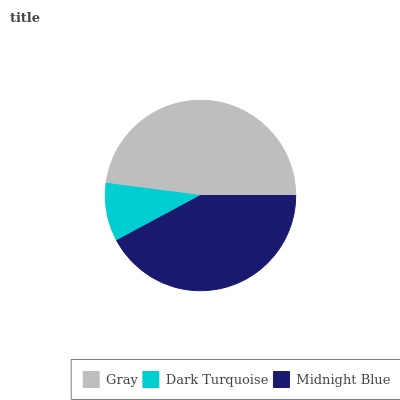Is Dark Turquoise the minimum?
Answer yes or no. Yes. Is Gray the maximum?
Answer yes or no. Yes. Is Midnight Blue the minimum?
Answer yes or no. No. Is Midnight Blue the maximum?
Answer yes or no. No. Is Midnight Blue greater than Dark Turquoise?
Answer yes or no. Yes. Is Dark Turquoise less than Midnight Blue?
Answer yes or no. Yes. Is Dark Turquoise greater than Midnight Blue?
Answer yes or no. No. Is Midnight Blue less than Dark Turquoise?
Answer yes or no. No. Is Midnight Blue the high median?
Answer yes or no. Yes. Is Midnight Blue the low median?
Answer yes or no. Yes. Is Dark Turquoise the high median?
Answer yes or no. No. Is Dark Turquoise the low median?
Answer yes or no. No. 